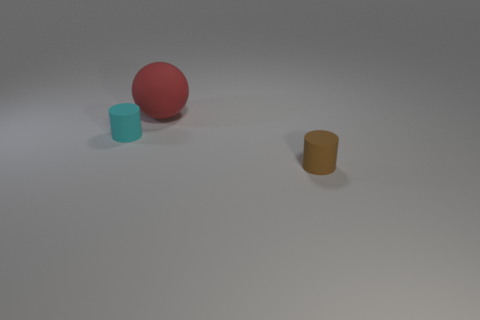Add 3 tiny cyan rubber cylinders. How many objects exist? 6 Subtract all balls. How many objects are left? 2 Add 1 brown things. How many brown things are left? 2 Add 2 large yellow rubber spheres. How many large yellow rubber spheres exist? 2 Subtract 0 cyan spheres. How many objects are left? 3 Subtract all tiny metallic objects. Subtract all large things. How many objects are left? 2 